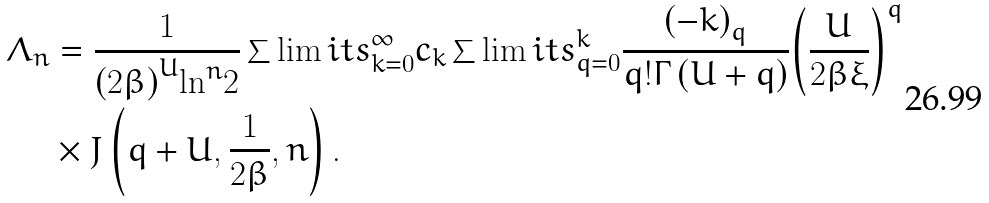<formula> <loc_0><loc_0><loc_500><loc_500>{ \Lambda _ { n } } & = \frac { 1 } { { { { \left ( { 2 \beta } \right ) } ^ { U } } } { { { \ln } ^ { n } } 2 } } \sum \lim i t s _ { k = 0 } ^ { \infty } { { c _ { k } } \sum \lim i t s _ { q = 0 } ^ { k } { \frac { { { { \left ( { - k } \right ) } _ { q } } } } { { q ! \Gamma \left ( { U + q } \right ) } } { { \left ( { \frac { U } { 2 \beta \xi } } \right ) } ^ { q } } } } \\ & \times J \left ( { q + U , \frac { 1 } { 2 \beta } , n } \right ) .</formula> 